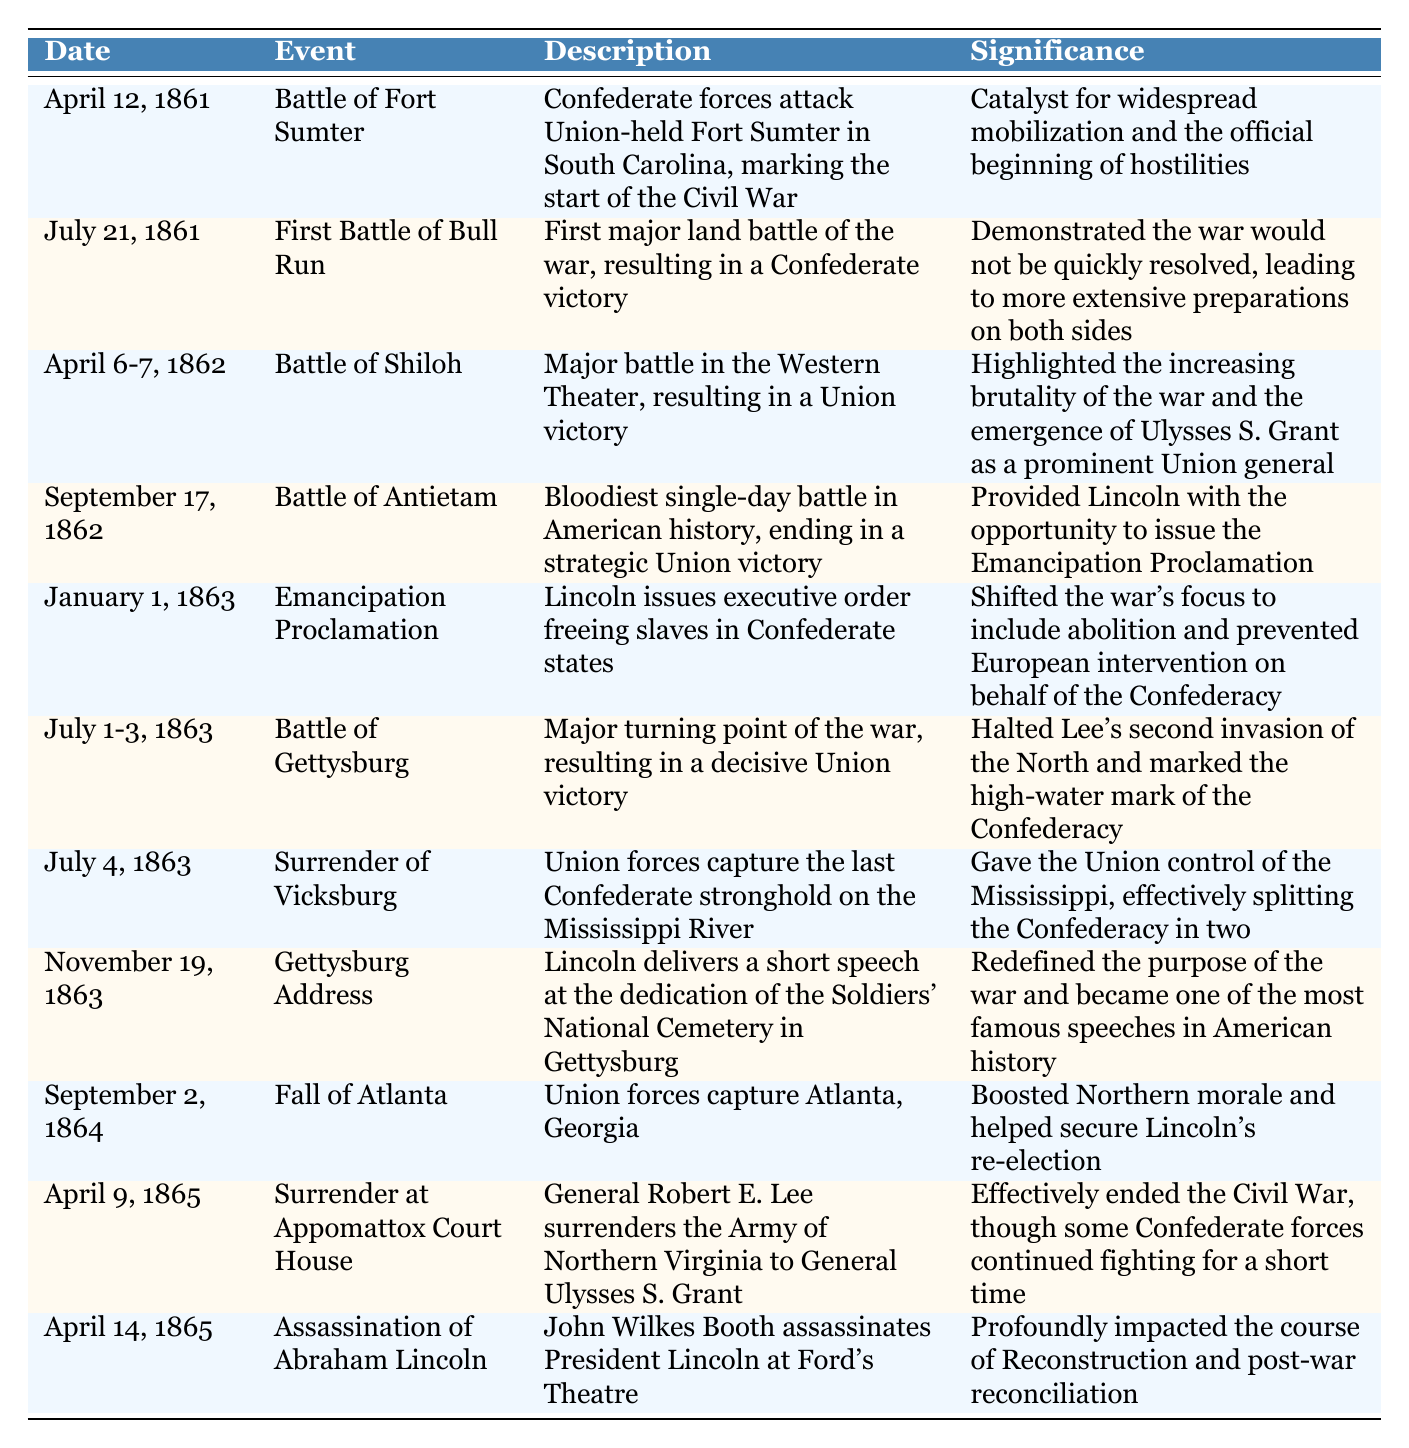What event marked the start of the Civil War? The table states that the Battle of Fort Sumter on April 12, 1861, marked the start of the Civil War, as it was the first conflict between Confederate forces and Union-held territory.
Answer: Battle of Fort Sumter Which battle was the bloodiest single-day battle in American history? According to the table, the Battle of Antietam on September 17, 1862, is noted as the bloodiest single-day battle, resulting in a strategic Union victory.
Answer: Battle of Antietam Did the Emancipation Proclamation focus solely on military strategy? The table reveals that the Emancipation Proclamation issued on January 1, 1863, shifted the war's focus to include abolition and aimed to prevent European intervention, indicating that it encompassed more than just military strategy.
Answer: No How many significant events happened in 1863? From the table, we observe that there are three events listed in 1863: the Emancipation Proclamation on January 1, the Battle of Gettysburg from July 1-3, and the Surrender of Vicksburg on July 4. Adding these gives us a total of three significant events in that year.
Answer: 3 Which event effectively ended the Civil War? The table indicates that the surrender at Appomattox Court House on April 9, 1865, by General Lee to General Grant effectively ended the Civil War, although some Confederate forces continued fighting for a short time after this event.
Answer: Surrender at Appomattox Court House What was the significance of the Gettysburg Address? The table describes the significance of the Gettysburg Address delivered by Lincoln on November 19, 1863, as redefining the purpose of the war, making it one of the most famous speeches in American history.
Answer: Redefined the purpose of the war Which event took place last in the timeline? Reviewing the dates in the table, the last event listed is the Assassination of Abraham Lincoln on April 14, 1865, which occurred after the Surrender at Appomattox Court House.
Answer: Assassination of Abraham Lincoln Compare the significance of the Battle of Gettysburg to the Battle of Vicksburg. The table indicates that both the Battle of Gettysburg and the Surrender of Vicksburg were turning points. Gettysburg halted Lee's invasion of the North, while Vicksburg gave the Union control of the Mississippi River, splitting the Confederacy. This shows that both events had significant strategic implications for the Union's success.
Answer: Both were major turning points for the Union What was the outcome of the Fall of Atlanta? The table states that the Fall of Atlanta on September 2, 1864, boosted Northern morale and helped secure Lincoln's re-election, illustrating its political and psychological significance.
Answer: Boosted Northern morale and helped secure Lincoln's re-election 